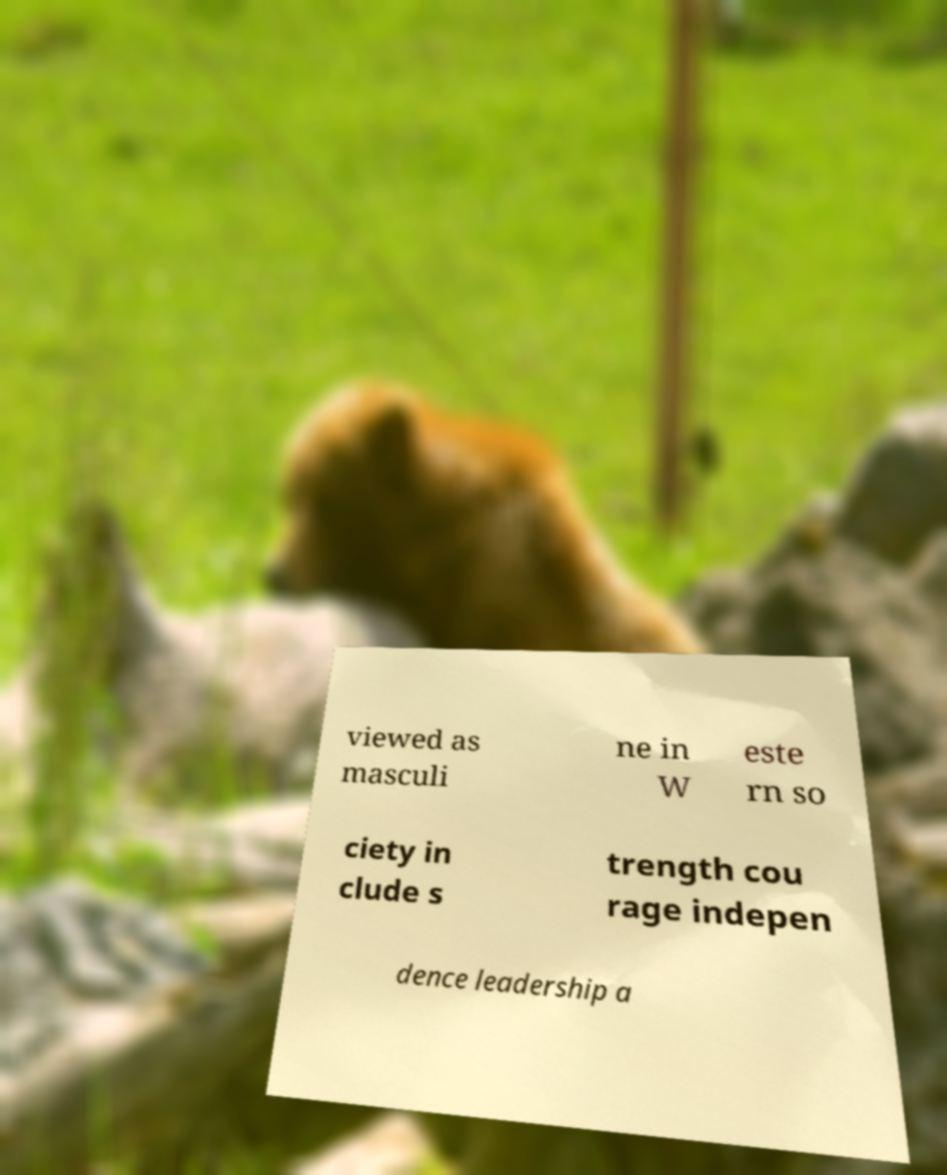I need the written content from this picture converted into text. Can you do that? viewed as masculi ne in W este rn so ciety in clude s trength cou rage indepen dence leadership a 